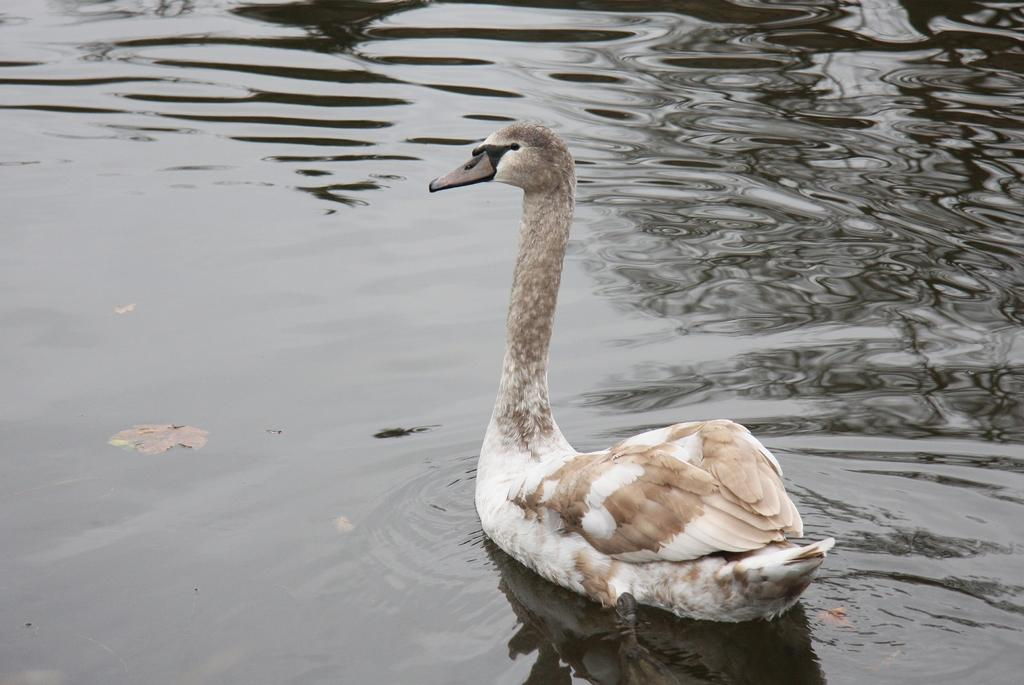What type of animal is in the image? There is a swan in the image. What plant-based object is in the image? There is a leaf in the image. Where are the swan and the leaf located? Both the swan and the leaf are in water. How many children are waving good-bye to the swan in the image? There are no children present in the image, and the swan is not interacting with anyone. What type of stocking is the swan wearing in the image? The swan is not wearing any stockings in the image. 